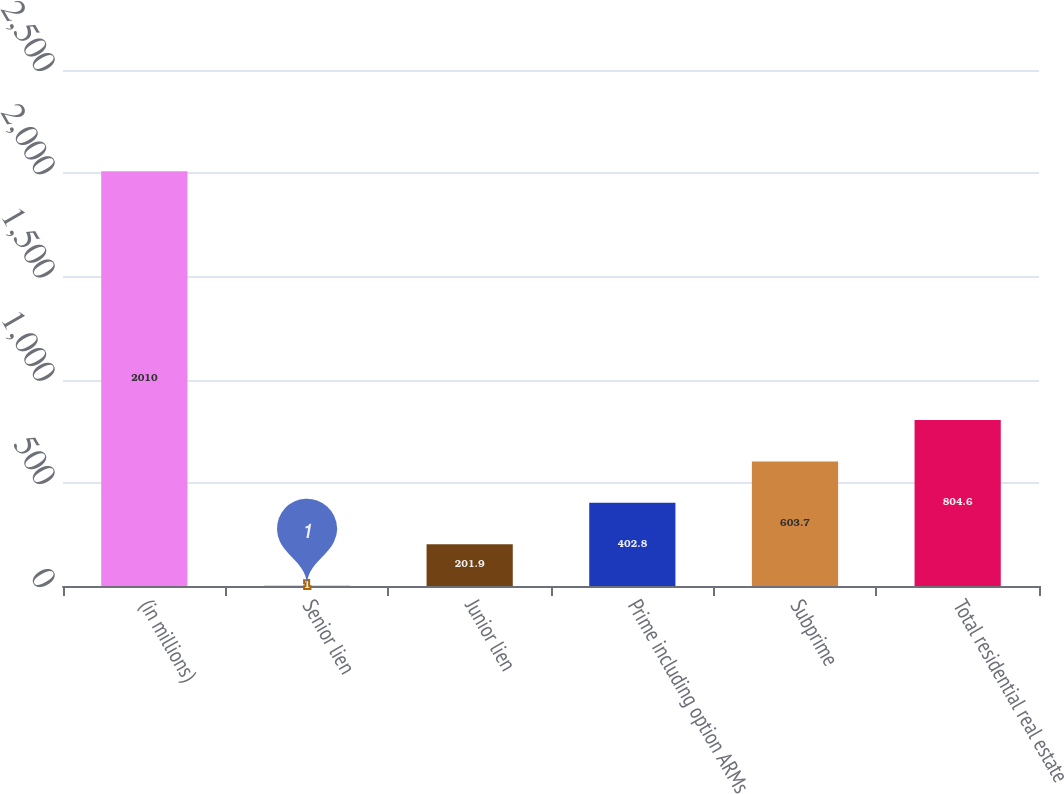<chart> <loc_0><loc_0><loc_500><loc_500><bar_chart><fcel>(in millions)<fcel>Senior lien<fcel>Junior lien<fcel>Prime including option ARMs<fcel>Subprime<fcel>Total residential real estate<nl><fcel>2010<fcel>1<fcel>201.9<fcel>402.8<fcel>603.7<fcel>804.6<nl></chart> 